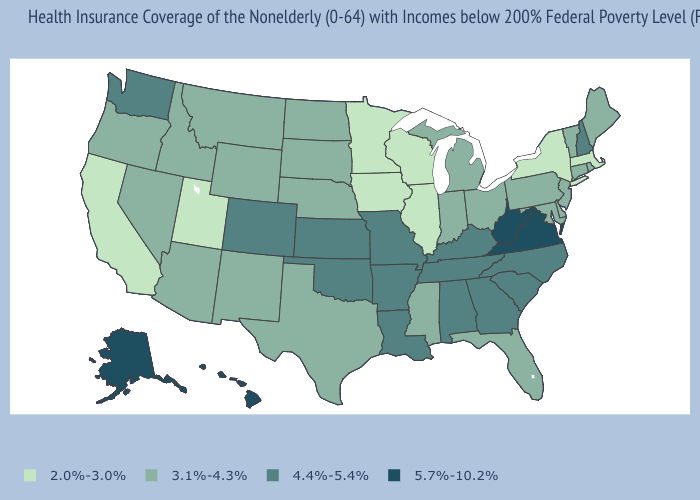Name the states that have a value in the range 4.4%-5.4%?
Keep it brief. Alabama, Arkansas, Colorado, Georgia, Kansas, Kentucky, Louisiana, Missouri, New Hampshire, North Carolina, Oklahoma, South Carolina, Tennessee, Washington. Does Connecticut have a higher value than Delaware?
Concise answer only. No. What is the value of Minnesota?
Be succinct. 2.0%-3.0%. Name the states that have a value in the range 5.7%-10.2%?
Write a very short answer. Alaska, Hawaii, Virginia, West Virginia. Name the states that have a value in the range 4.4%-5.4%?
Write a very short answer. Alabama, Arkansas, Colorado, Georgia, Kansas, Kentucky, Louisiana, Missouri, New Hampshire, North Carolina, Oklahoma, South Carolina, Tennessee, Washington. Does the map have missing data?
Be succinct. No. Does the first symbol in the legend represent the smallest category?
Write a very short answer. Yes. Does Alabama have a lower value than Kansas?
Write a very short answer. No. Name the states that have a value in the range 4.4%-5.4%?
Concise answer only. Alabama, Arkansas, Colorado, Georgia, Kansas, Kentucky, Louisiana, Missouri, New Hampshire, North Carolina, Oklahoma, South Carolina, Tennessee, Washington. What is the highest value in the USA?
Short answer required. 5.7%-10.2%. Which states have the lowest value in the Northeast?
Answer briefly. Massachusetts, New York. What is the value of Alaska?
Keep it brief. 5.7%-10.2%. Which states have the lowest value in the USA?
Answer briefly. California, Illinois, Iowa, Massachusetts, Minnesota, New York, Utah, Wisconsin. Is the legend a continuous bar?
Be succinct. No. What is the value of Utah?
Keep it brief. 2.0%-3.0%. 